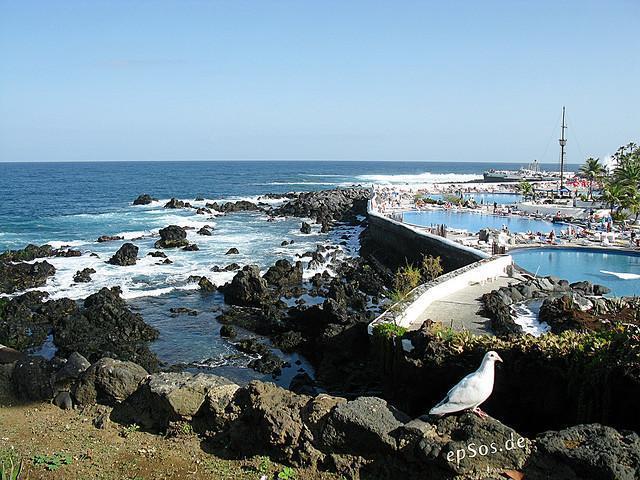How many boats are there?
Give a very brief answer. 2. 